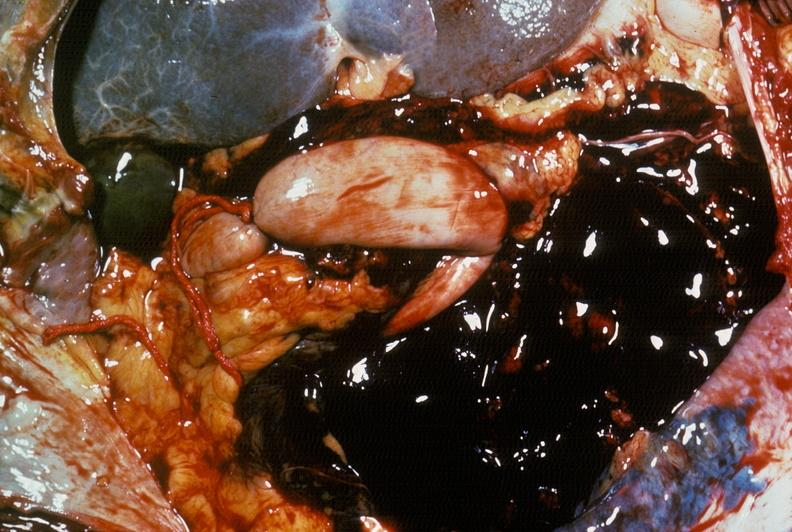where is this area in the body?
Answer the question using a single word or phrase. Abdomen 